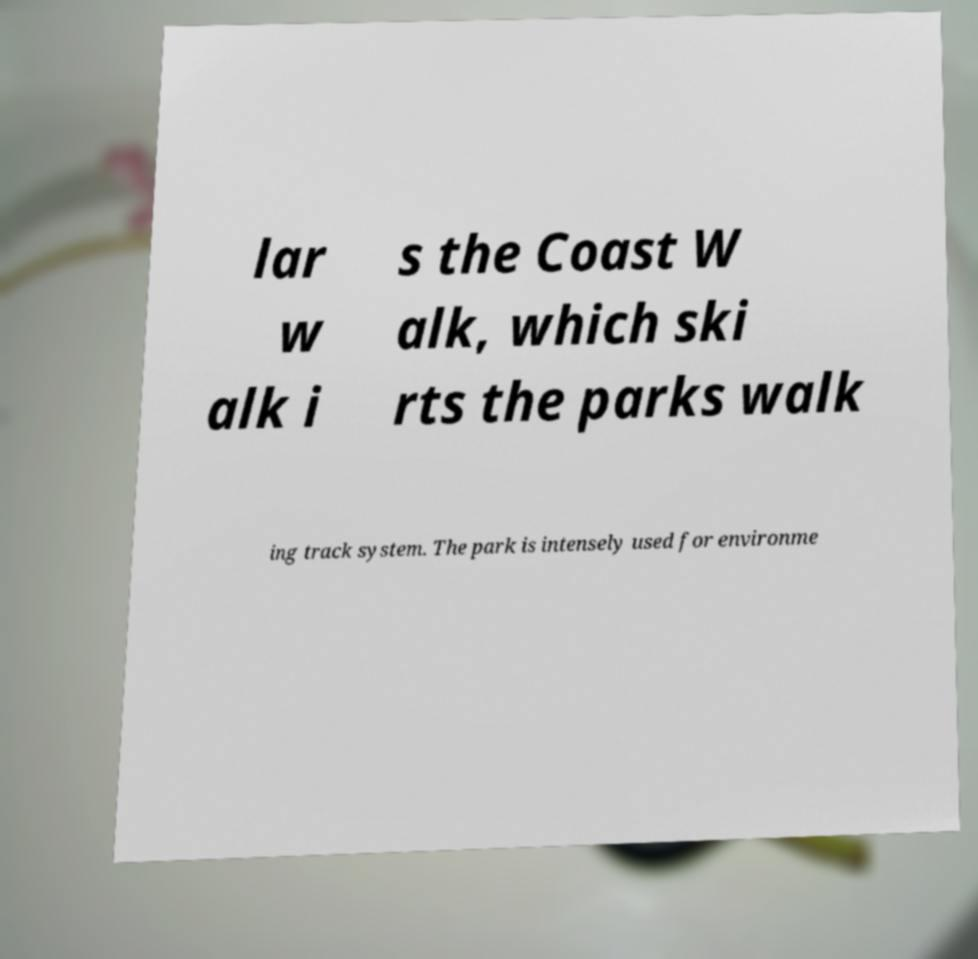Please read and relay the text visible in this image. What does it say? lar w alk i s the Coast W alk, which ski rts the parks walk ing track system. The park is intensely used for environme 